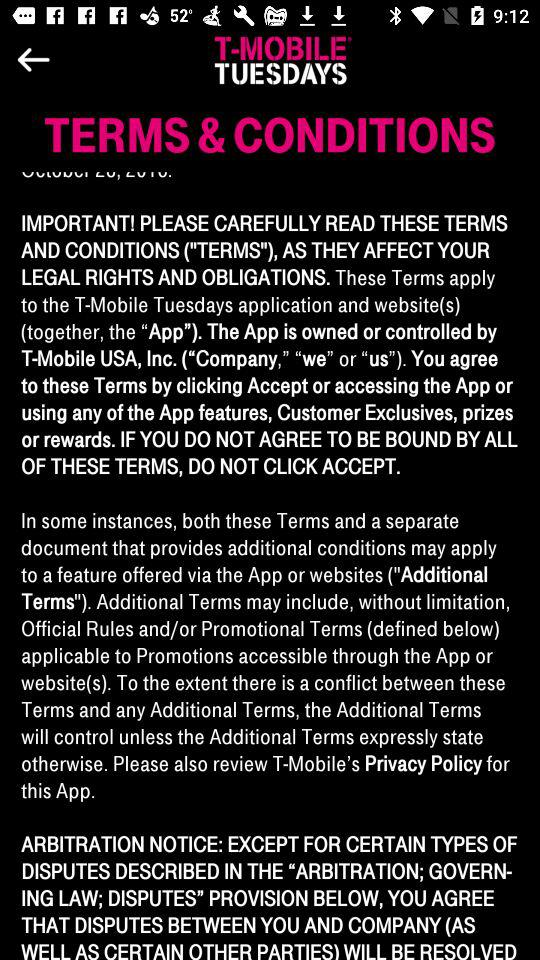How much time is left to end the countdown? The time left is 5 days, 18 hours and 51 minutes. 